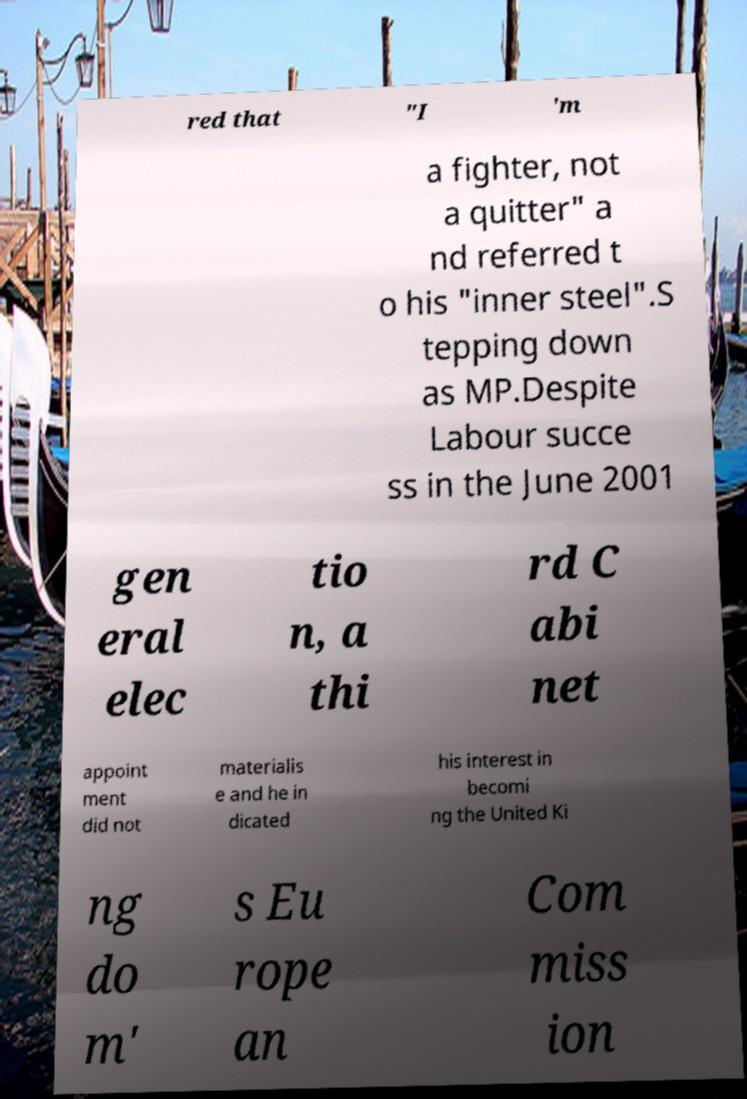Can you accurately transcribe the text from the provided image for me? red that "I 'm a fighter, not a quitter" a nd referred t o his "inner steel".S tepping down as MP.Despite Labour succe ss in the June 2001 gen eral elec tio n, a thi rd C abi net appoint ment did not materialis e and he in dicated his interest in becomi ng the United Ki ng do m' s Eu rope an Com miss ion 